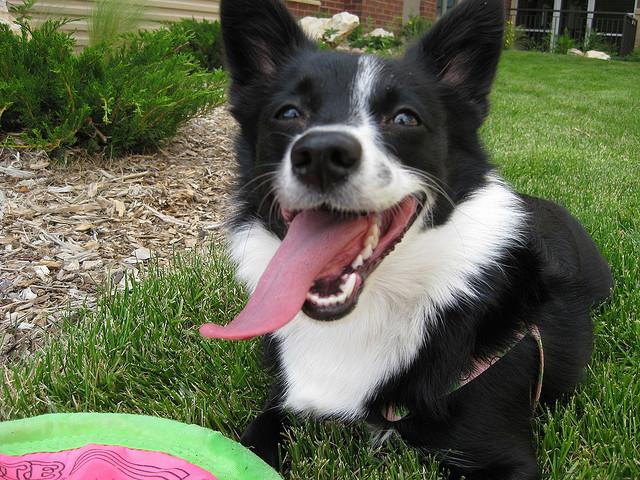What color is the dog's collar?
Write a very short answer. Pink. What is the dog lying on?
Write a very short answer. Grass. What kind of dog is in the picture?
Answer briefly. Border collie. Where are the rocks?
Write a very short answer. Behind dog. 